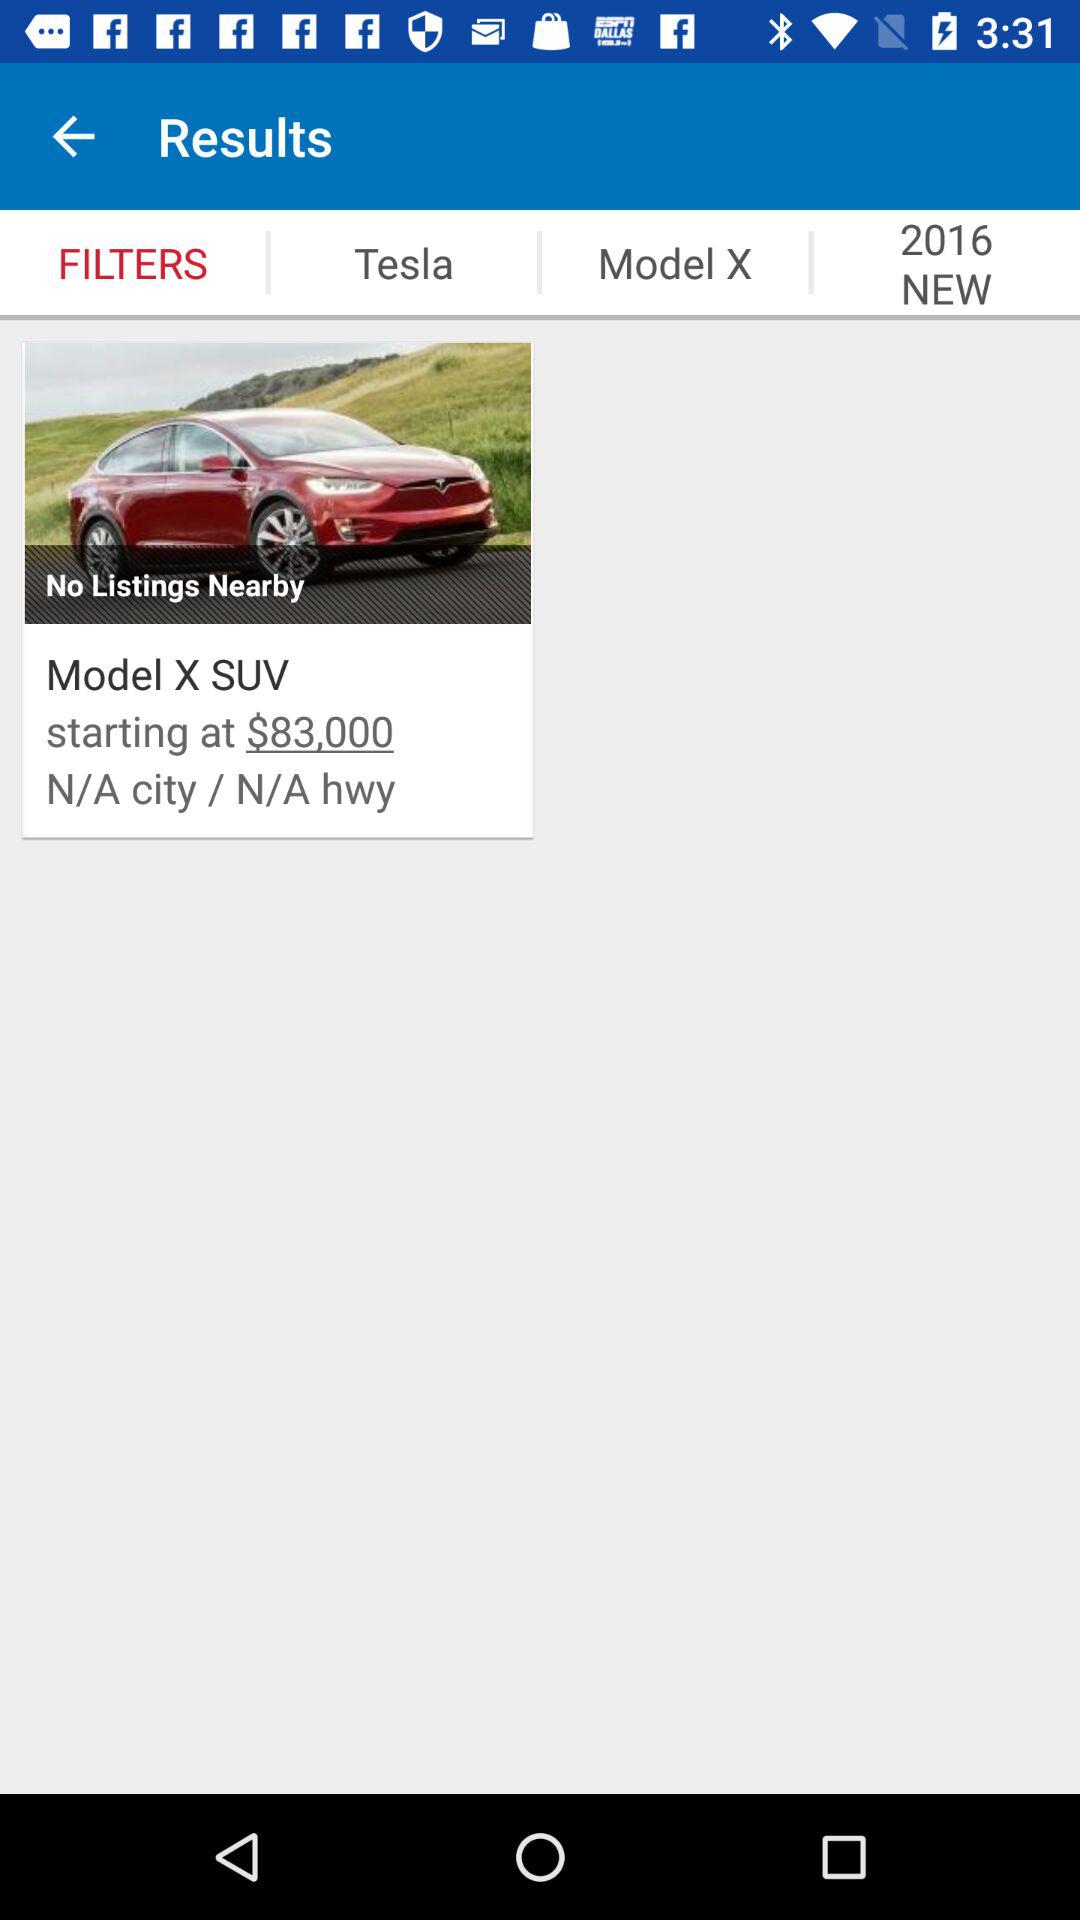What is the starting price of the Model X SUV? The starting price of the Model X SUV is $83,000. 